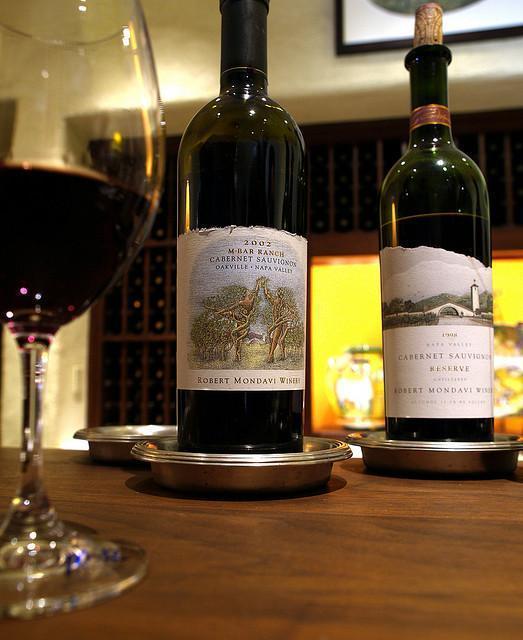How many bottles are visible?
Give a very brief answer. 3. 